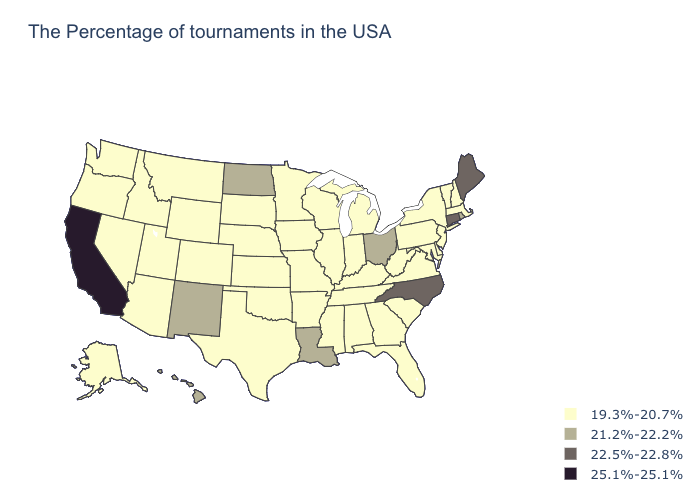Among the states that border North Dakota , which have the highest value?
Quick response, please. Minnesota, South Dakota, Montana. Does California have the highest value in the USA?
Be succinct. Yes. Does Virginia have a lower value than Minnesota?
Write a very short answer. No. What is the lowest value in the West?
Concise answer only. 19.3%-20.7%. What is the highest value in the MidWest ?
Write a very short answer. 21.2%-22.2%. Name the states that have a value in the range 19.3%-20.7%?
Short answer required. Massachusetts, New Hampshire, Vermont, New York, New Jersey, Delaware, Maryland, Pennsylvania, Virginia, South Carolina, West Virginia, Florida, Georgia, Michigan, Kentucky, Indiana, Alabama, Tennessee, Wisconsin, Illinois, Mississippi, Missouri, Arkansas, Minnesota, Iowa, Kansas, Nebraska, Oklahoma, Texas, South Dakota, Wyoming, Colorado, Utah, Montana, Arizona, Idaho, Nevada, Washington, Oregon, Alaska. Does Michigan have the lowest value in the MidWest?
Answer briefly. Yes. Name the states that have a value in the range 22.5%-22.8%?
Answer briefly. Maine, Connecticut, North Carolina. What is the value of Oregon?
Keep it brief. 19.3%-20.7%. Name the states that have a value in the range 25.1%-25.1%?
Short answer required. California. Does Delaware have the highest value in the South?
Short answer required. No. What is the value of New York?
Short answer required. 19.3%-20.7%. What is the value of Louisiana?
Concise answer only. 21.2%-22.2%. Which states have the highest value in the USA?
Give a very brief answer. California. Does Ohio have the highest value in the MidWest?
Keep it brief. Yes. 